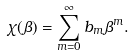Convert formula to latex. <formula><loc_0><loc_0><loc_500><loc_500>\chi ( \beta ) = \sum _ { m = 0 } ^ { \infty } b _ { m } \beta ^ { m } .</formula> 